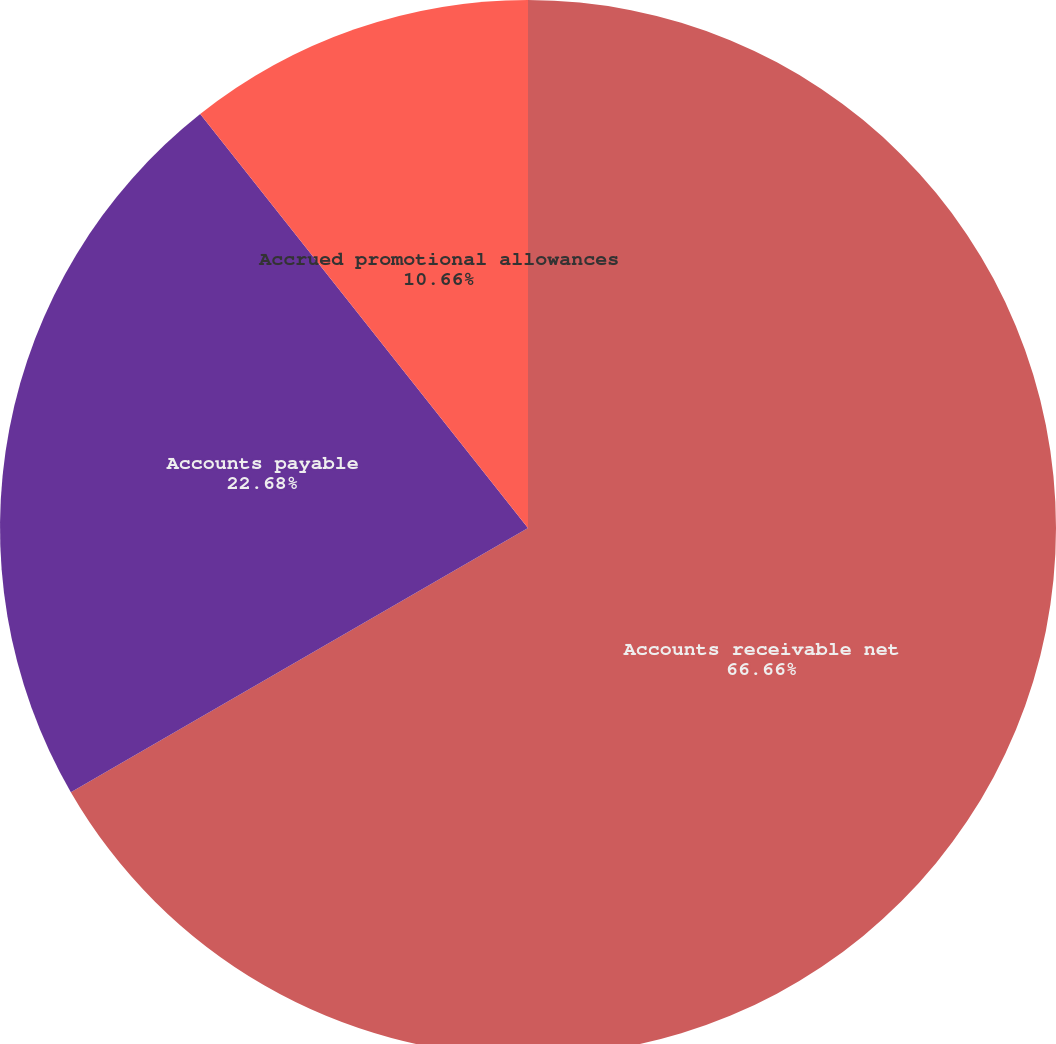Convert chart to OTSL. <chart><loc_0><loc_0><loc_500><loc_500><pie_chart><fcel>Accounts receivable net<fcel>Accounts payable<fcel>Accrued promotional allowances<nl><fcel>66.66%<fcel>22.68%<fcel>10.66%<nl></chart> 